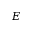<formula> <loc_0><loc_0><loc_500><loc_500>E</formula> 